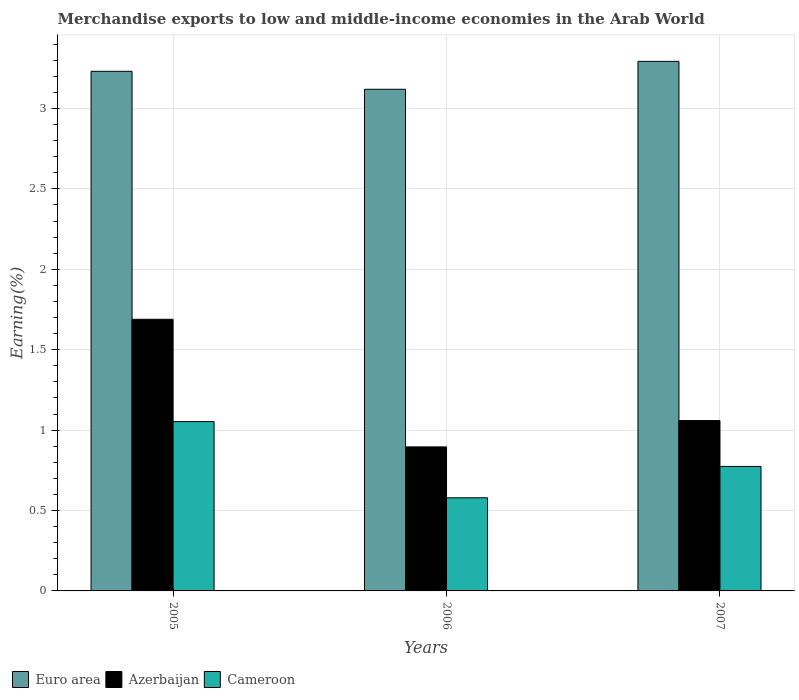How many different coloured bars are there?
Give a very brief answer. 3. Are the number of bars per tick equal to the number of legend labels?
Give a very brief answer. Yes. How many bars are there on the 3rd tick from the left?
Provide a succinct answer. 3. How many bars are there on the 1st tick from the right?
Your response must be concise. 3. What is the label of the 1st group of bars from the left?
Provide a succinct answer. 2005. In how many cases, is the number of bars for a given year not equal to the number of legend labels?
Provide a succinct answer. 0. What is the percentage of amount earned from merchandise exports in Azerbaijan in 2005?
Provide a short and direct response. 1.69. Across all years, what is the maximum percentage of amount earned from merchandise exports in Cameroon?
Ensure brevity in your answer.  1.05. Across all years, what is the minimum percentage of amount earned from merchandise exports in Cameroon?
Make the answer very short. 0.58. In which year was the percentage of amount earned from merchandise exports in Euro area maximum?
Offer a very short reply. 2007. In which year was the percentage of amount earned from merchandise exports in Cameroon minimum?
Provide a short and direct response. 2006. What is the total percentage of amount earned from merchandise exports in Azerbaijan in the graph?
Make the answer very short. 3.64. What is the difference between the percentage of amount earned from merchandise exports in Cameroon in 2005 and that in 2007?
Ensure brevity in your answer.  0.28. What is the difference between the percentage of amount earned from merchandise exports in Euro area in 2007 and the percentage of amount earned from merchandise exports in Cameroon in 2005?
Offer a very short reply. 2.24. What is the average percentage of amount earned from merchandise exports in Azerbaijan per year?
Keep it short and to the point. 1.21. In the year 2005, what is the difference between the percentage of amount earned from merchandise exports in Cameroon and percentage of amount earned from merchandise exports in Euro area?
Ensure brevity in your answer.  -2.18. In how many years, is the percentage of amount earned from merchandise exports in Euro area greater than 1.2 %?
Your answer should be compact. 3. What is the ratio of the percentage of amount earned from merchandise exports in Cameroon in 2005 to that in 2007?
Keep it short and to the point. 1.36. What is the difference between the highest and the second highest percentage of amount earned from merchandise exports in Azerbaijan?
Give a very brief answer. 0.63. What is the difference between the highest and the lowest percentage of amount earned from merchandise exports in Euro area?
Your answer should be compact. 0.17. Is the sum of the percentage of amount earned from merchandise exports in Cameroon in 2005 and 2007 greater than the maximum percentage of amount earned from merchandise exports in Euro area across all years?
Offer a terse response. No. What does the 3rd bar from the left in 2006 represents?
Provide a succinct answer. Cameroon. How many years are there in the graph?
Provide a succinct answer. 3. What is the difference between two consecutive major ticks on the Y-axis?
Provide a short and direct response. 0.5. Does the graph contain any zero values?
Make the answer very short. No. What is the title of the graph?
Make the answer very short. Merchandise exports to low and middle-income economies in the Arab World. What is the label or title of the Y-axis?
Your answer should be very brief. Earning(%). What is the Earning(%) in Euro area in 2005?
Ensure brevity in your answer.  3.23. What is the Earning(%) in Azerbaijan in 2005?
Give a very brief answer. 1.69. What is the Earning(%) of Cameroon in 2005?
Your answer should be compact. 1.05. What is the Earning(%) in Euro area in 2006?
Your response must be concise. 3.12. What is the Earning(%) of Azerbaijan in 2006?
Give a very brief answer. 0.9. What is the Earning(%) in Cameroon in 2006?
Provide a succinct answer. 0.58. What is the Earning(%) in Euro area in 2007?
Keep it short and to the point. 3.29. What is the Earning(%) in Azerbaijan in 2007?
Provide a succinct answer. 1.06. What is the Earning(%) of Cameroon in 2007?
Offer a very short reply. 0.77. Across all years, what is the maximum Earning(%) in Euro area?
Give a very brief answer. 3.29. Across all years, what is the maximum Earning(%) in Azerbaijan?
Your response must be concise. 1.69. Across all years, what is the maximum Earning(%) of Cameroon?
Your answer should be compact. 1.05. Across all years, what is the minimum Earning(%) in Euro area?
Provide a short and direct response. 3.12. Across all years, what is the minimum Earning(%) in Azerbaijan?
Give a very brief answer. 0.9. Across all years, what is the minimum Earning(%) in Cameroon?
Provide a succinct answer. 0.58. What is the total Earning(%) in Euro area in the graph?
Offer a very short reply. 9.64. What is the total Earning(%) of Azerbaijan in the graph?
Your response must be concise. 3.64. What is the total Earning(%) of Cameroon in the graph?
Keep it short and to the point. 2.41. What is the difference between the Earning(%) of Euro area in 2005 and that in 2006?
Offer a terse response. 0.11. What is the difference between the Earning(%) of Azerbaijan in 2005 and that in 2006?
Your answer should be very brief. 0.79. What is the difference between the Earning(%) in Cameroon in 2005 and that in 2006?
Make the answer very short. 0.47. What is the difference between the Earning(%) of Euro area in 2005 and that in 2007?
Offer a terse response. -0.06. What is the difference between the Earning(%) in Azerbaijan in 2005 and that in 2007?
Your answer should be compact. 0.63. What is the difference between the Earning(%) in Cameroon in 2005 and that in 2007?
Keep it short and to the point. 0.28. What is the difference between the Earning(%) in Euro area in 2006 and that in 2007?
Your response must be concise. -0.17. What is the difference between the Earning(%) of Azerbaijan in 2006 and that in 2007?
Keep it short and to the point. -0.16. What is the difference between the Earning(%) in Cameroon in 2006 and that in 2007?
Keep it short and to the point. -0.2. What is the difference between the Earning(%) in Euro area in 2005 and the Earning(%) in Azerbaijan in 2006?
Ensure brevity in your answer.  2.34. What is the difference between the Earning(%) in Euro area in 2005 and the Earning(%) in Cameroon in 2006?
Offer a terse response. 2.65. What is the difference between the Earning(%) of Azerbaijan in 2005 and the Earning(%) of Cameroon in 2006?
Keep it short and to the point. 1.11. What is the difference between the Earning(%) of Euro area in 2005 and the Earning(%) of Azerbaijan in 2007?
Keep it short and to the point. 2.17. What is the difference between the Earning(%) of Euro area in 2005 and the Earning(%) of Cameroon in 2007?
Offer a very short reply. 2.46. What is the difference between the Earning(%) in Azerbaijan in 2005 and the Earning(%) in Cameroon in 2007?
Provide a short and direct response. 0.91. What is the difference between the Earning(%) in Euro area in 2006 and the Earning(%) in Azerbaijan in 2007?
Your response must be concise. 2.06. What is the difference between the Earning(%) of Euro area in 2006 and the Earning(%) of Cameroon in 2007?
Provide a short and direct response. 2.35. What is the difference between the Earning(%) in Azerbaijan in 2006 and the Earning(%) in Cameroon in 2007?
Give a very brief answer. 0.12. What is the average Earning(%) of Euro area per year?
Provide a succinct answer. 3.21. What is the average Earning(%) of Azerbaijan per year?
Provide a succinct answer. 1.21. What is the average Earning(%) of Cameroon per year?
Ensure brevity in your answer.  0.8. In the year 2005, what is the difference between the Earning(%) of Euro area and Earning(%) of Azerbaijan?
Give a very brief answer. 1.54. In the year 2005, what is the difference between the Earning(%) of Euro area and Earning(%) of Cameroon?
Offer a very short reply. 2.18. In the year 2005, what is the difference between the Earning(%) in Azerbaijan and Earning(%) in Cameroon?
Provide a short and direct response. 0.64. In the year 2006, what is the difference between the Earning(%) in Euro area and Earning(%) in Azerbaijan?
Make the answer very short. 2.22. In the year 2006, what is the difference between the Earning(%) of Euro area and Earning(%) of Cameroon?
Make the answer very short. 2.54. In the year 2006, what is the difference between the Earning(%) of Azerbaijan and Earning(%) of Cameroon?
Offer a terse response. 0.32. In the year 2007, what is the difference between the Earning(%) in Euro area and Earning(%) in Azerbaijan?
Give a very brief answer. 2.23. In the year 2007, what is the difference between the Earning(%) of Euro area and Earning(%) of Cameroon?
Your response must be concise. 2.52. In the year 2007, what is the difference between the Earning(%) in Azerbaijan and Earning(%) in Cameroon?
Your response must be concise. 0.28. What is the ratio of the Earning(%) of Euro area in 2005 to that in 2006?
Provide a succinct answer. 1.04. What is the ratio of the Earning(%) of Azerbaijan in 2005 to that in 2006?
Provide a short and direct response. 1.89. What is the ratio of the Earning(%) in Cameroon in 2005 to that in 2006?
Offer a very short reply. 1.82. What is the ratio of the Earning(%) in Euro area in 2005 to that in 2007?
Ensure brevity in your answer.  0.98. What is the ratio of the Earning(%) in Azerbaijan in 2005 to that in 2007?
Ensure brevity in your answer.  1.59. What is the ratio of the Earning(%) of Cameroon in 2005 to that in 2007?
Give a very brief answer. 1.36. What is the ratio of the Earning(%) in Euro area in 2006 to that in 2007?
Provide a short and direct response. 0.95. What is the ratio of the Earning(%) in Azerbaijan in 2006 to that in 2007?
Your answer should be compact. 0.85. What is the ratio of the Earning(%) of Cameroon in 2006 to that in 2007?
Provide a short and direct response. 0.75. What is the difference between the highest and the second highest Earning(%) of Euro area?
Your answer should be compact. 0.06. What is the difference between the highest and the second highest Earning(%) in Azerbaijan?
Make the answer very short. 0.63. What is the difference between the highest and the second highest Earning(%) of Cameroon?
Provide a succinct answer. 0.28. What is the difference between the highest and the lowest Earning(%) in Euro area?
Your answer should be very brief. 0.17. What is the difference between the highest and the lowest Earning(%) of Azerbaijan?
Provide a succinct answer. 0.79. What is the difference between the highest and the lowest Earning(%) in Cameroon?
Provide a succinct answer. 0.47. 